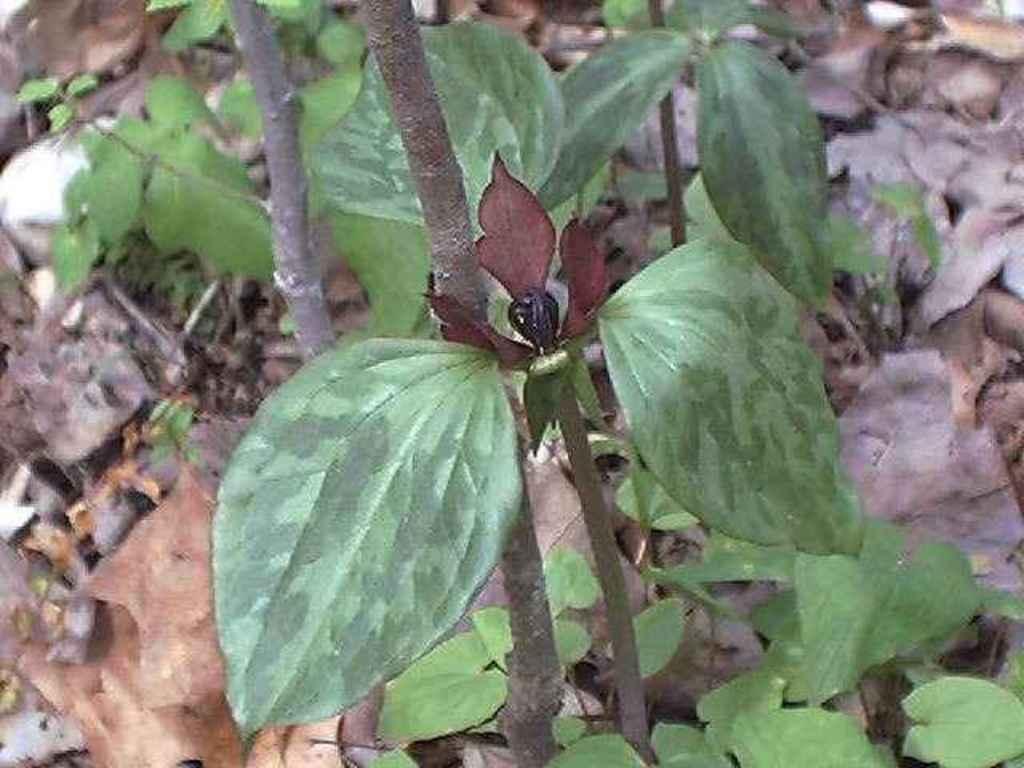How would you summarize this image in a sentence or two? As we can see in the image there are plants and dry leaves. 